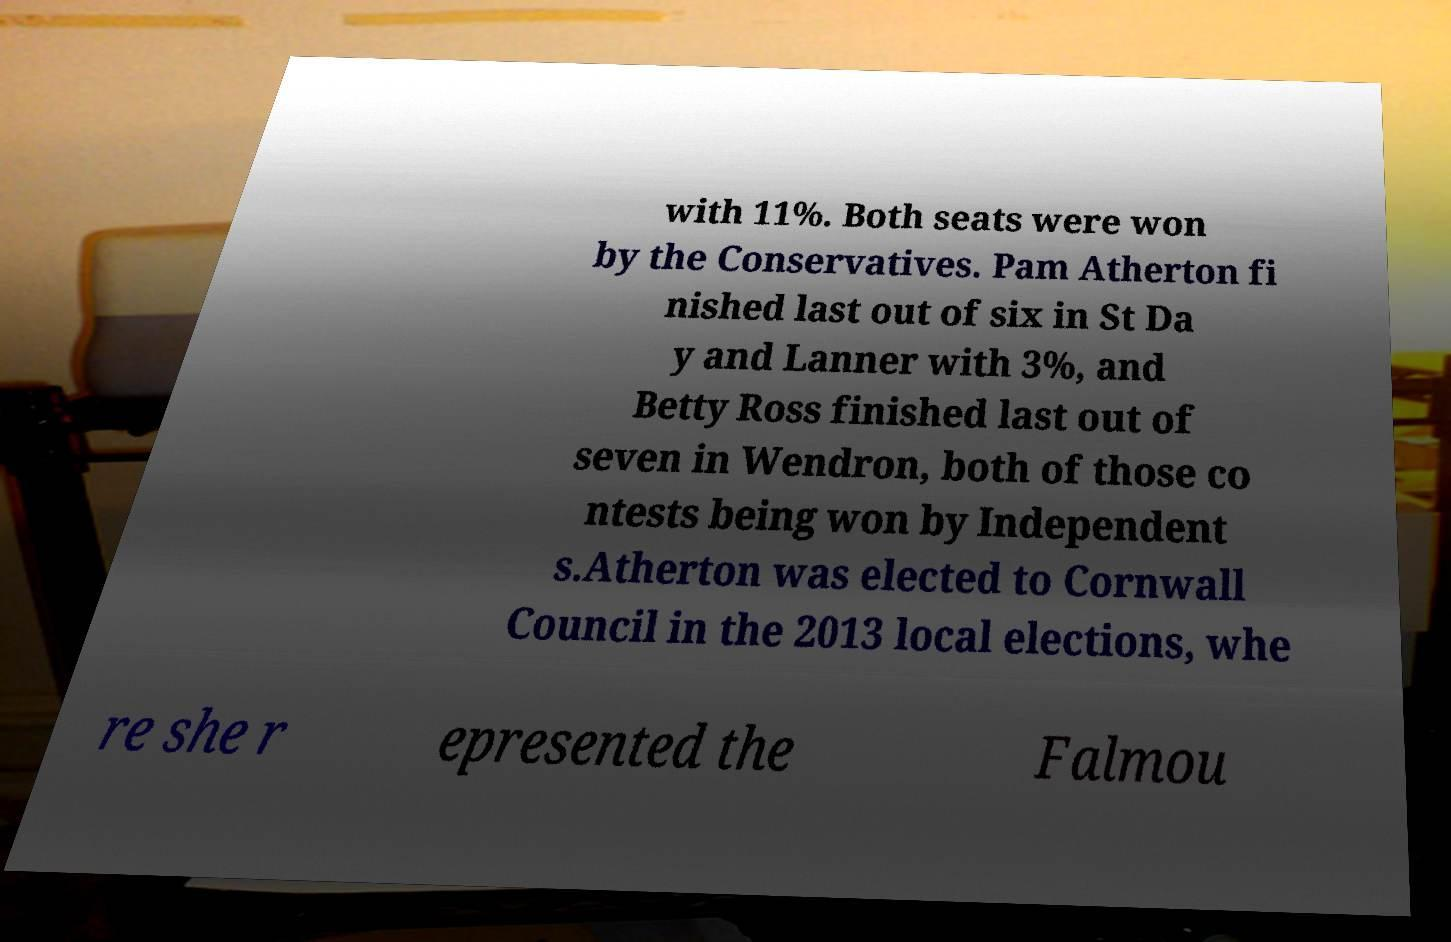Please read and relay the text visible in this image. What does it say? with 11%. Both seats were won by the Conservatives. Pam Atherton fi nished last out of six in St Da y and Lanner with 3%, and Betty Ross finished last out of seven in Wendron, both of those co ntests being won by Independent s.Atherton was elected to Cornwall Council in the 2013 local elections, whe re she r epresented the Falmou 